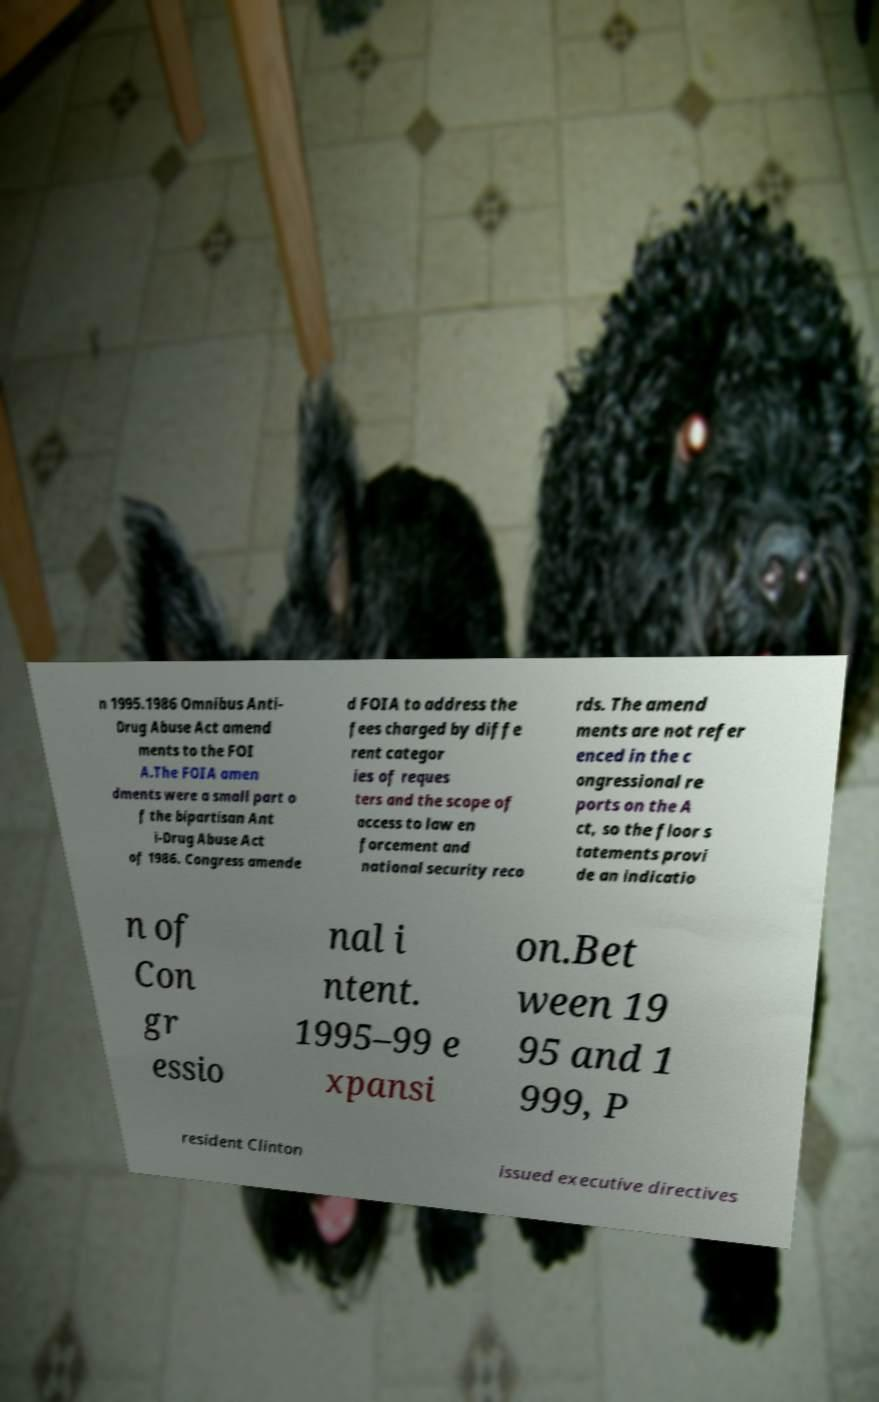There's text embedded in this image that I need extracted. Can you transcribe it verbatim? n 1995.1986 Omnibus Anti- Drug Abuse Act amend ments to the FOI A.The FOIA amen dments were a small part o f the bipartisan Ant i-Drug Abuse Act of 1986. Congress amende d FOIA to address the fees charged by diffe rent categor ies of reques ters and the scope of access to law en forcement and national security reco rds. The amend ments are not refer enced in the c ongressional re ports on the A ct, so the floor s tatements provi de an indicatio n of Con gr essio nal i ntent. 1995–99 e xpansi on.Bet ween 19 95 and 1 999, P resident Clinton issued executive directives 